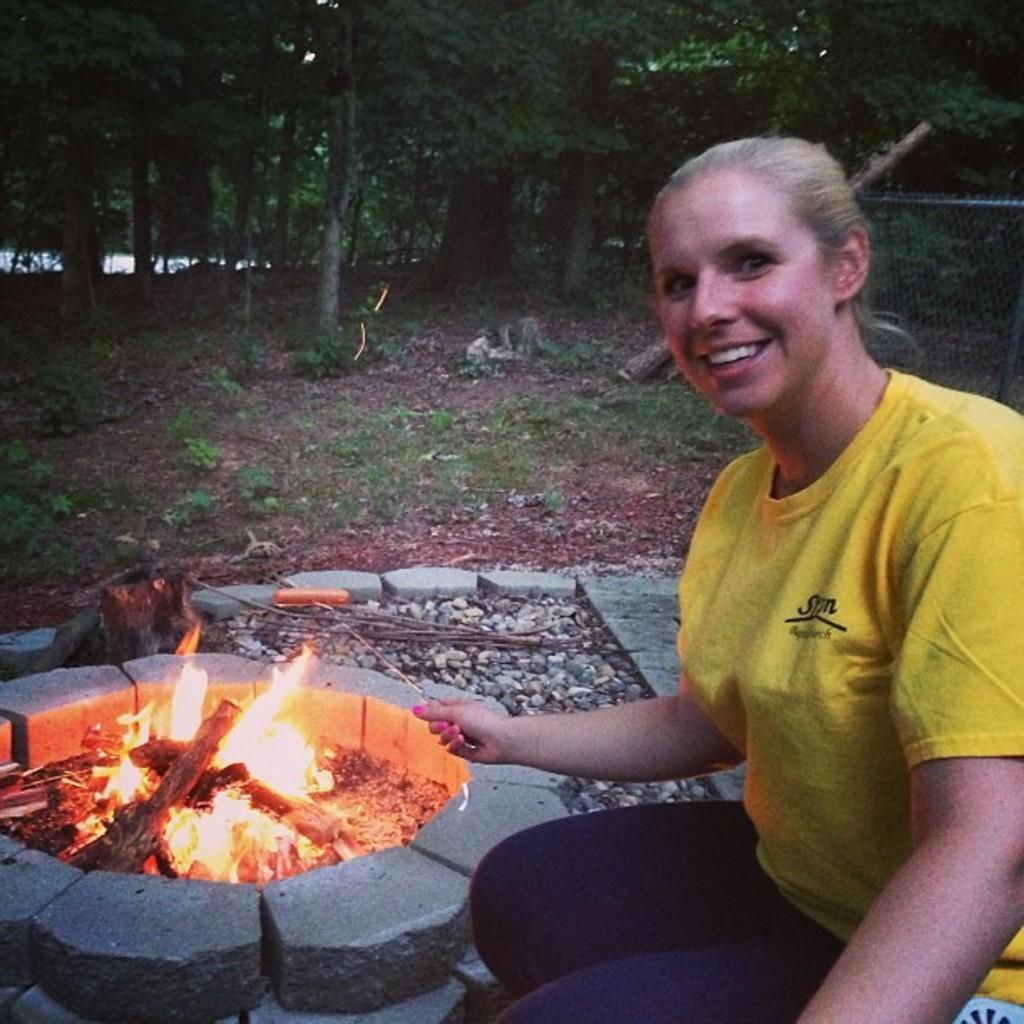Who is present in the image? There is a woman in the image. What is the woman's expression? The woman is smiling. What can be seen on the left side of the image? There is a campfire on the left side of the image. What is visible in the background of the image? There are trees and plants in the background of the image. What type of surface is at the bottom of the image? There are stones at the bottom of the image. What type of machine can be seen operating in the background of the image? There is no machine present in the image; it features a woman, a campfire, trees, plants, and stones. 